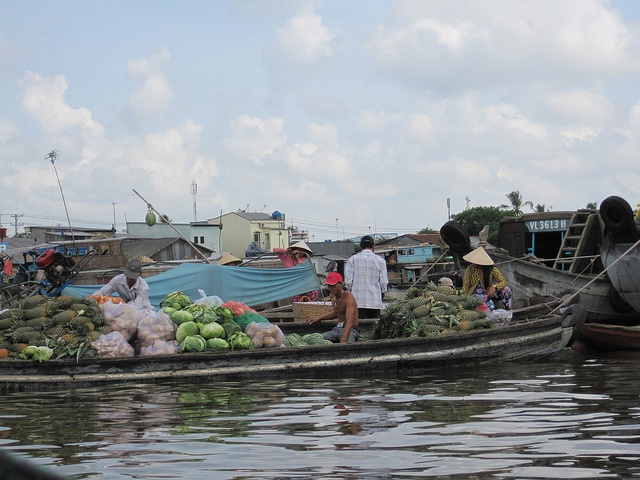Describe the objects in this image and their specific colors. I can see boat in lightblue, black, gray, and darkgray tones, boat in lightblue, black, and gray tones, boat in lightblue, black, and gray tones, people in lightblue, darkgray, black, and gray tones, and people in lightblue, gray, maroon, black, and brown tones in this image. 